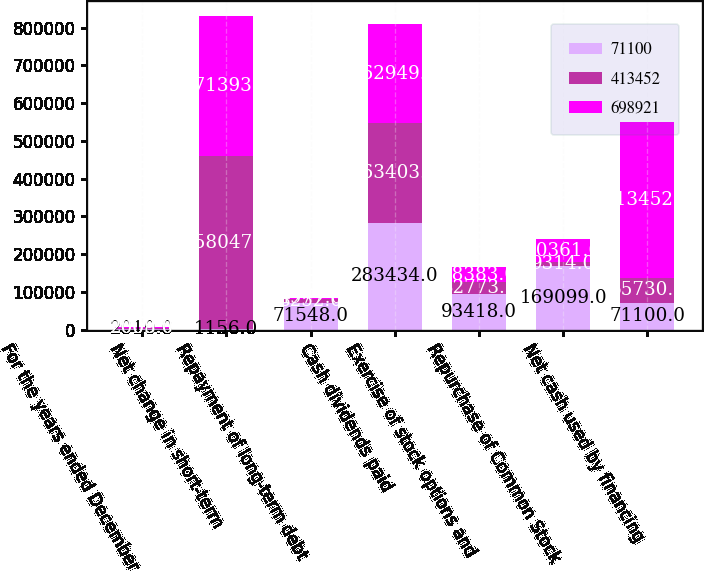<chart> <loc_0><loc_0><loc_500><loc_500><stacked_bar_chart><ecel><fcel>For the years ended December<fcel>Net change in short-term<fcel>Repayment of long-term debt<fcel>Cash dividends paid<fcel>Exercise of stock options and<fcel>Repurchase of Common Stock<fcel>Net cash used by financing<nl><fcel>71100<fcel>2010<fcel>1156<fcel>71548<fcel>283434<fcel>93418<fcel>169099<fcel>71100<nl><fcel>413452<fcel>2009<fcel>458047<fcel>8252<fcel>263403<fcel>32773<fcel>9314<fcel>65730.5<nl><fcel>698921<fcel>2008<fcel>371393<fcel>4977<fcel>262949<fcel>38383<fcel>60361<fcel>413452<nl></chart> 